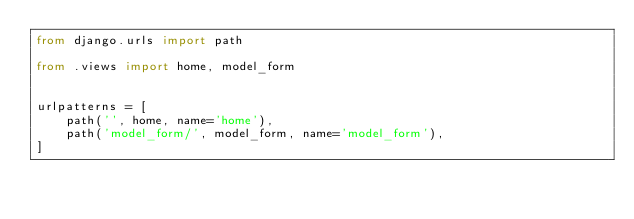Convert code to text. <code><loc_0><loc_0><loc_500><loc_500><_Python_>from django.urls import path

from .views import home, model_form


urlpatterns = [
    path('', home, name='home'),
    path('model_form/', model_form, name='model_form'),
]
</code> 